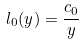<formula> <loc_0><loc_0><loc_500><loc_500>l _ { 0 } ( y ) = \frac { c _ { 0 } } { y }</formula> 